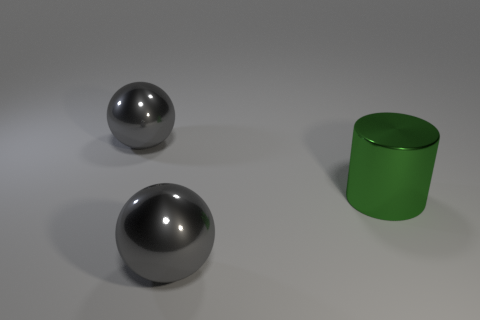What number of other objects are the same color as the metal cylinder?
Make the answer very short. 0. How big is the gray shiny thing that is right of the gray ball that is on the left side of the thing in front of the large green metal cylinder?
Your answer should be compact. Large. How many objects are either large gray shiny things that are behind the green thing or big objects that are in front of the big green shiny cylinder?
Ensure brevity in your answer.  2. What is the shape of the large green metal thing?
Provide a succinct answer. Cylinder. What number of other objects are the same material as the green cylinder?
Make the answer very short. 2. What is the material of the ball on the right side of the big gray thing to the left of the big gray shiny sphere in front of the big shiny cylinder?
Keep it short and to the point. Metal. Are any large green cylinders visible?
Keep it short and to the point. Yes. Do the cylinder and the big ball that is behind the green cylinder have the same color?
Keep it short and to the point. No. What is the color of the cylinder?
Offer a terse response. Green. Is there any other thing that is the same shape as the green metallic object?
Make the answer very short. No. 